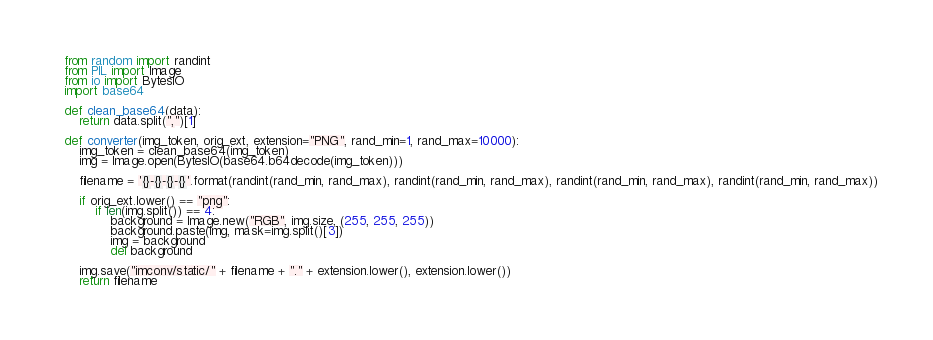<code> <loc_0><loc_0><loc_500><loc_500><_Python_>from random import randint
from PIL import Image
from io import BytesIO
import base64

def clean_base64(data):
    return data.split(",")[1]

def converter(img_token, orig_ext, extension="PNG", rand_min=1, rand_max=10000):
    img_token = clean_base64(img_token)
    img = Image.open(BytesIO(base64.b64decode(img_token)))

    filename = '{}-{}-{}-{}'.format(randint(rand_min, rand_max), randint(rand_min, rand_max), randint(rand_min, rand_max), randint(rand_min, rand_max))

    if orig_ext.lower() == "png":
        if len(img.split()) == 4:
            background = Image.new("RGB", img.size, (255, 255, 255))
            background.paste(img, mask=img.split()[3])
            img = background
            del background

    img.save("imconv/static/" + filename + "." + extension.lower(), extension.lower())
    return filename
</code> 